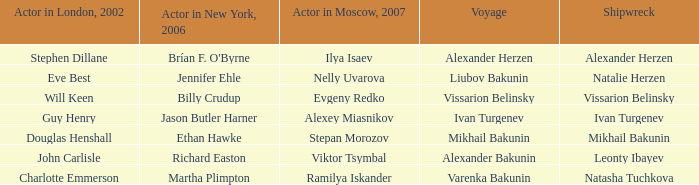Who played the role of leonty ibayev in the 2007 shipwreck depiction, originating from moscow? Viktor Tsymbal. 